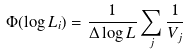Convert formula to latex. <formula><loc_0><loc_0><loc_500><loc_500>\Phi ( \log L _ { i } ) = \frac { 1 } { \Delta \log L } \sum _ { j } \frac { 1 } { V _ { j } }</formula> 